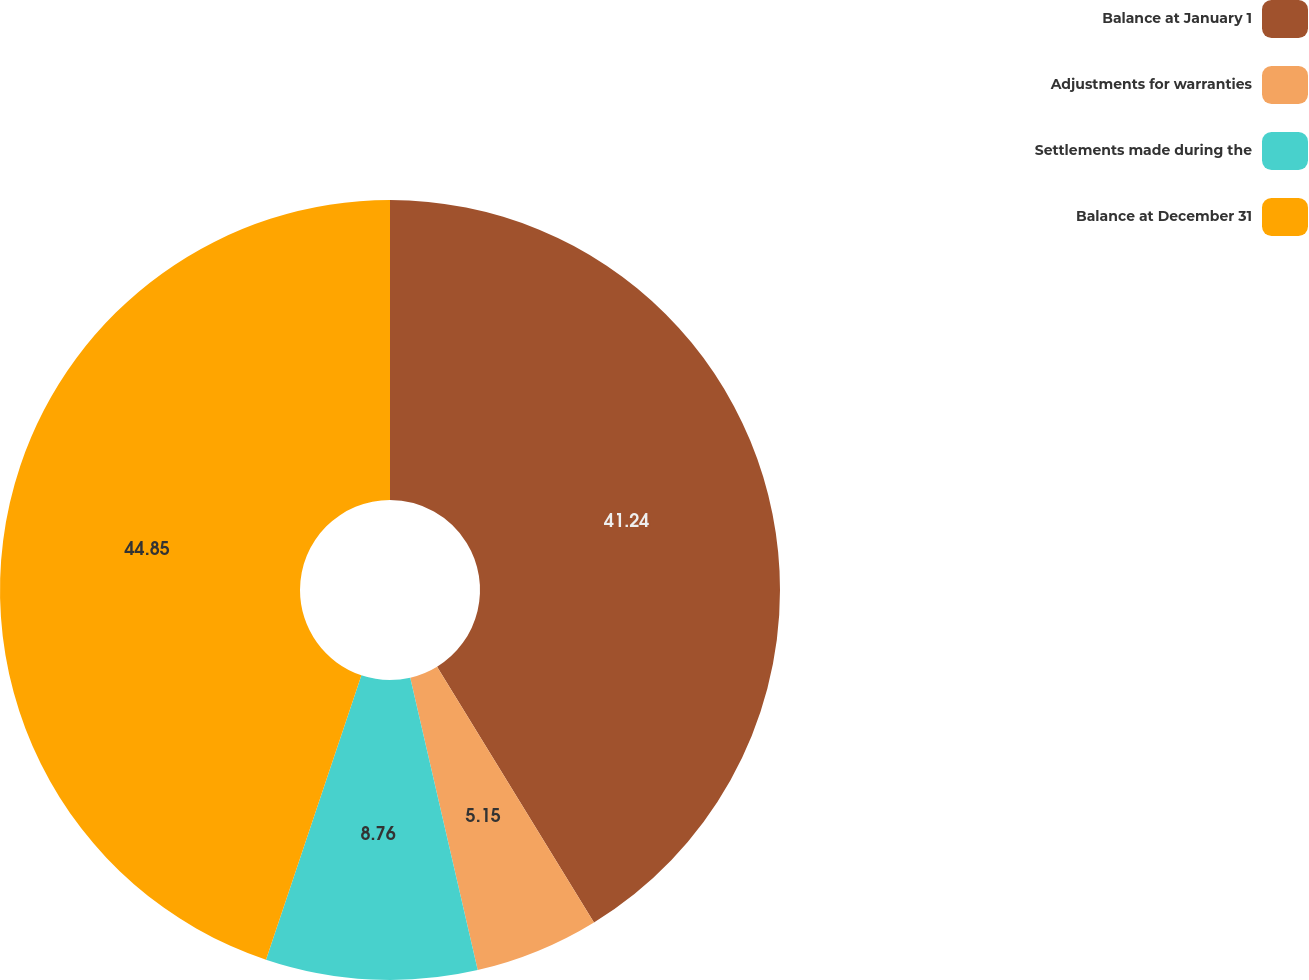Convert chart to OTSL. <chart><loc_0><loc_0><loc_500><loc_500><pie_chart><fcel>Balance at January 1<fcel>Adjustments for warranties<fcel>Settlements made during the<fcel>Balance at December 31<nl><fcel>41.24%<fcel>5.15%<fcel>8.76%<fcel>44.85%<nl></chart> 